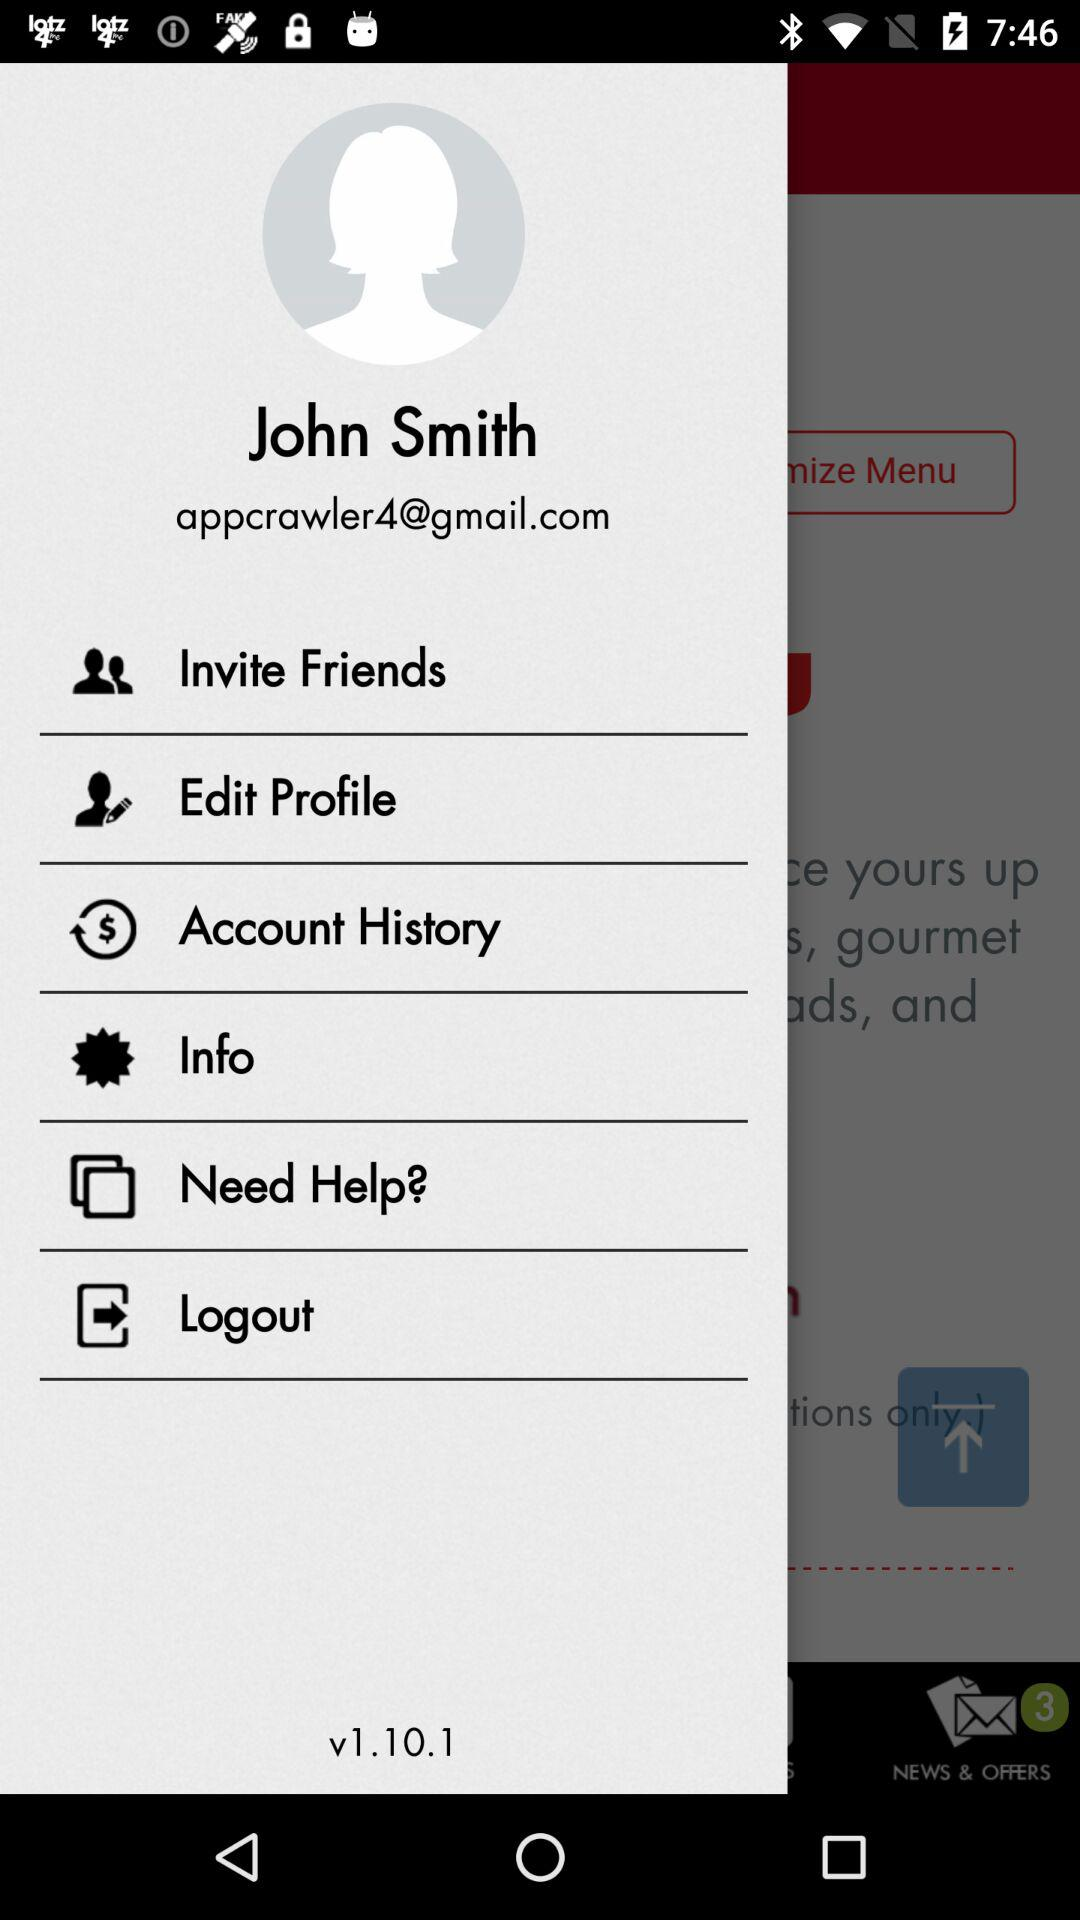What is the version of the application? The version of the application is v1.10.1. 